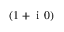<formula> <loc_0><loc_0><loc_500><loc_500>( 1 + i 0 )</formula> 